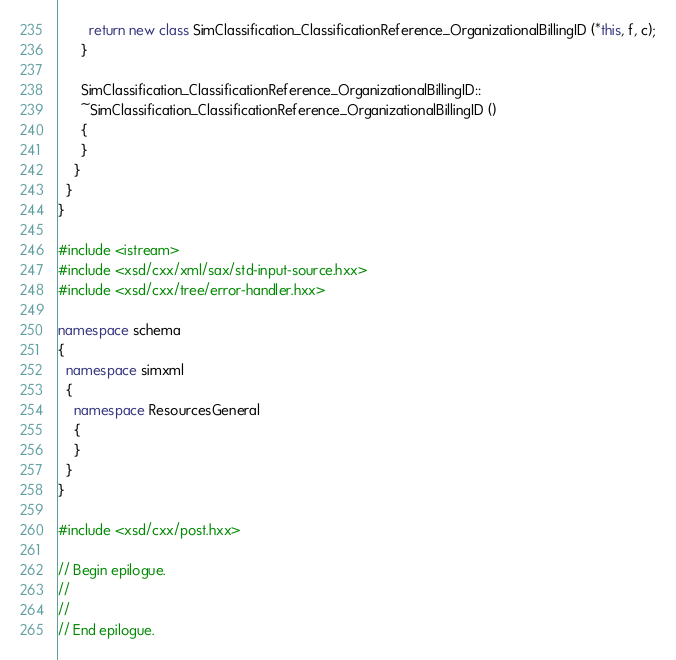<code> <loc_0><loc_0><loc_500><loc_500><_C++_>        return new class SimClassification_ClassificationReference_OrganizationalBillingID (*this, f, c);
      }

      SimClassification_ClassificationReference_OrganizationalBillingID::
      ~SimClassification_ClassificationReference_OrganizationalBillingID ()
      {
      }
    }
  }
}

#include <istream>
#include <xsd/cxx/xml/sax/std-input-source.hxx>
#include <xsd/cxx/tree/error-handler.hxx>

namespace schema
{
  namespace simxml
  {
    namespace ResourcesGeneral
    {
    }
  }
}

#include <xsd/cxx/post.hxx>

// Begin epilogue.
//
//
// End epilogue.

</code> 